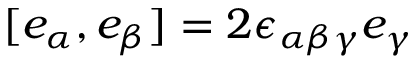<formula> <loc_0><loc_0><loc_500><loc_500>[ e _ { \alpha } , e _ { \beta } ] = 2 \epsilon _ { \alpha \beta \gamma } e _ { \gamma }</formula> 